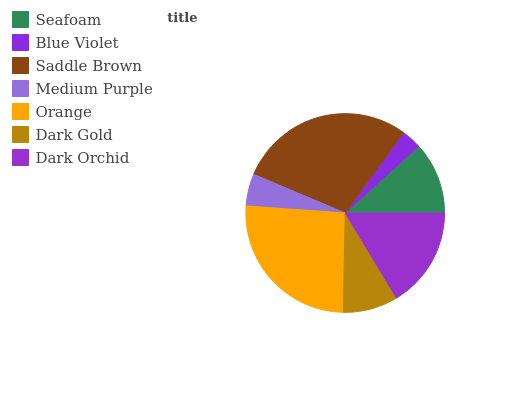Is Blue Violet the minimum?
Answer yes or no. Yes. Is Saddle Brown the maximum?
Answer yes or no. Yes. Is Saddle Brown the minimum?
Answer yes or no. No. Is Blue Violet the maximum?
Answer yes or no. No. Is Saddle Brown greater than Blue Violet?
Answer yes or no. Yes. Is Blue Violet less than Saddle Brown?
Answer yes or no. Yes. Is Blue Violet greater than Saddle Brown?
Answer yes or no. No. Is Saddle Brown less than Blue Violet?
Answer yes or no. No. Is Seafoam the high median?
Answer yes or no. Yes. Is Seafoam the low median?
Answer yes or no. Yes. Is Orange the high median?
Answer yes or no. No. Is Saddle Brown the low median?
Answer yes or no. No. 